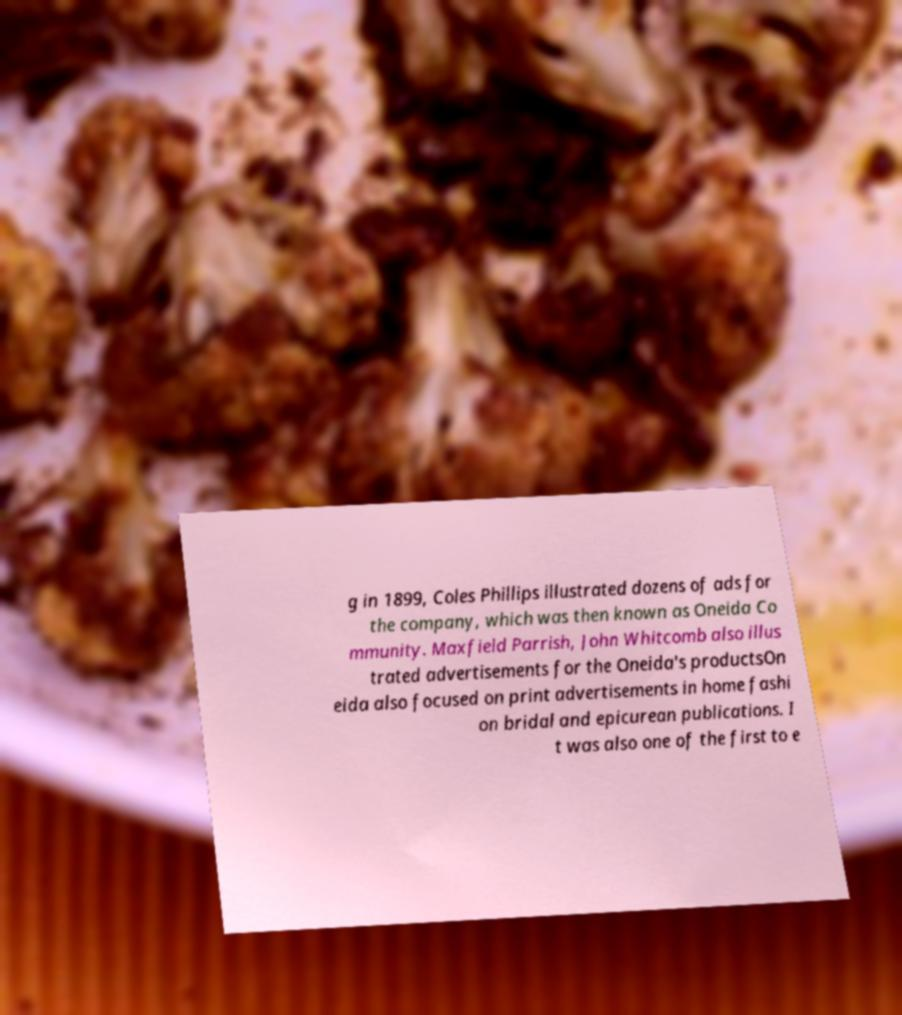Could you extract and type out the text from this image? g in 1899, Coles Phillips illustrated dozens of ads for the company, which was then known as Oneida Co mmunity. Maxfield Parrish, John Whitcomb also illus trated advertisements for the Oneida's productsOn eida also focused on print advertisements in home fashi on bridal and epicurean publications. I t was also one of the first to e 